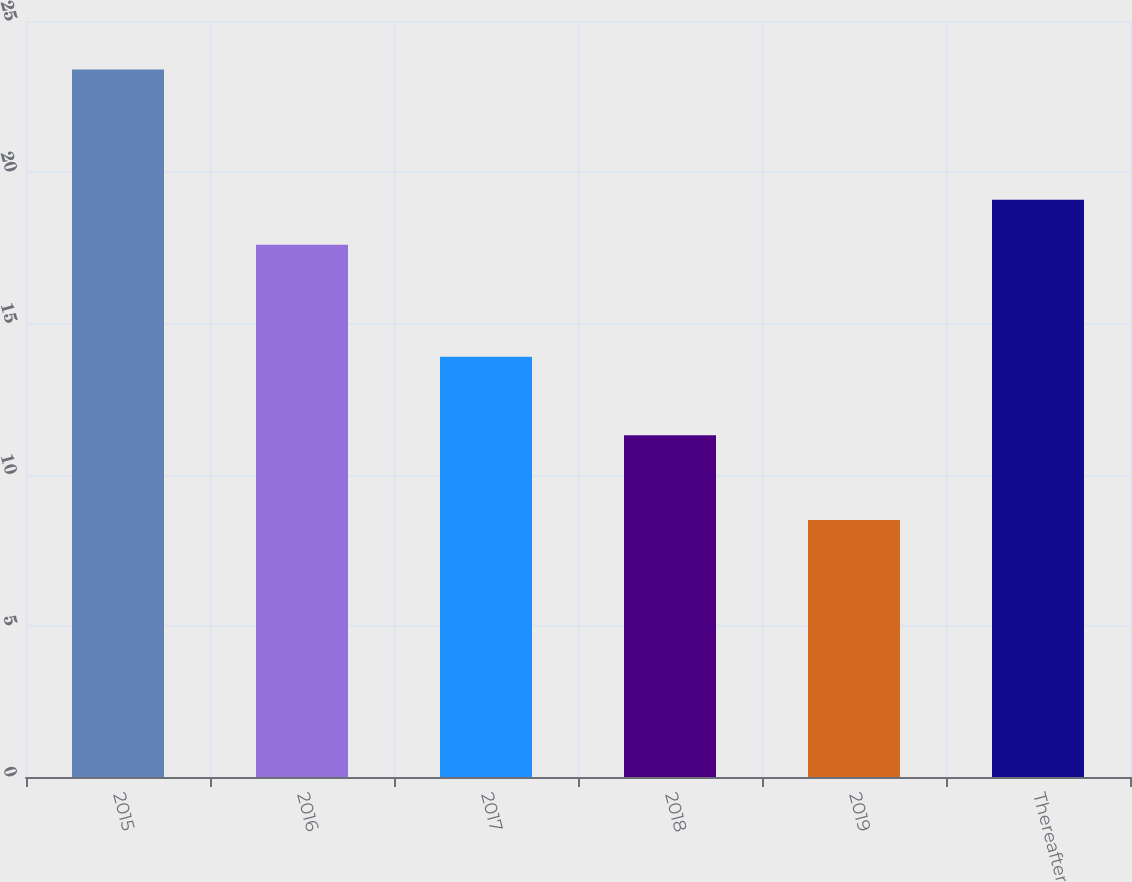<chart> <loc_0><loc_0><loc_500><loc_500><bar_chart><fcel>2015<fcel>2016<fcel>2017<fcel>2018<fcel>2019<fcel>Thereafter<nl><fcel>23.4<fcel>17.6<fcel>13.9<fcel>11.3<fcel>8.5<fcel>19.09<nl></chart> 